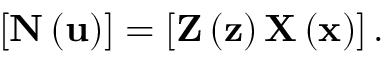<formula> <loc_0><loc_0><loc_500><loc_500>\left [ N \left ( u \right ) \right ] = \left [ Z \left ( z \right ) X \left ( x \right ) \right ] .</formula> 